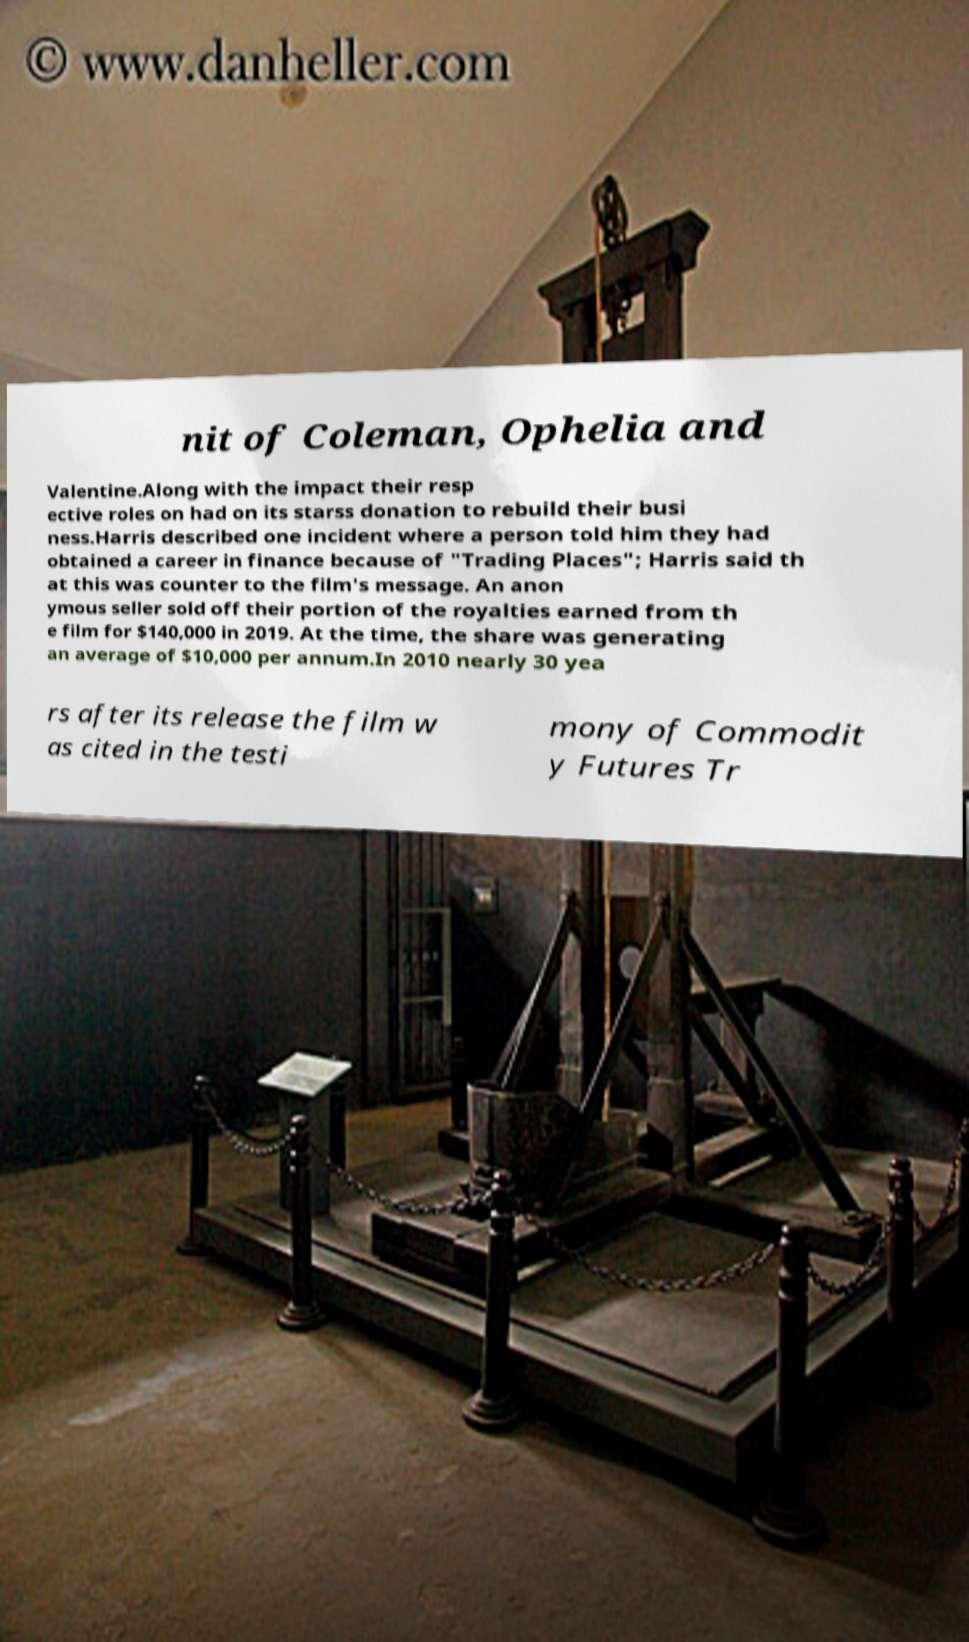Can you read and provide the text displayed in the image?This photo seems to have some interesting text. Can you extract and type it out for me? nit of Coleman, Ophelia and Valentine.Along with the impact their resp ective roles on had on its starss donation to rebuild their busi ness.Harris described one incident where a person told him they had obtained a career in finance because of "Trading Places"; Harris said th at this was counter to the film's message. An anon ymous seller sold off their portion of the royalties earned from th e film for $140,000 in 2019. At the time, the share was generating an average of $10,000 per annum.In 2010 nearly 30 yea rs after its release the film w as cited in the testi mony of Commodit y Futures Tr 